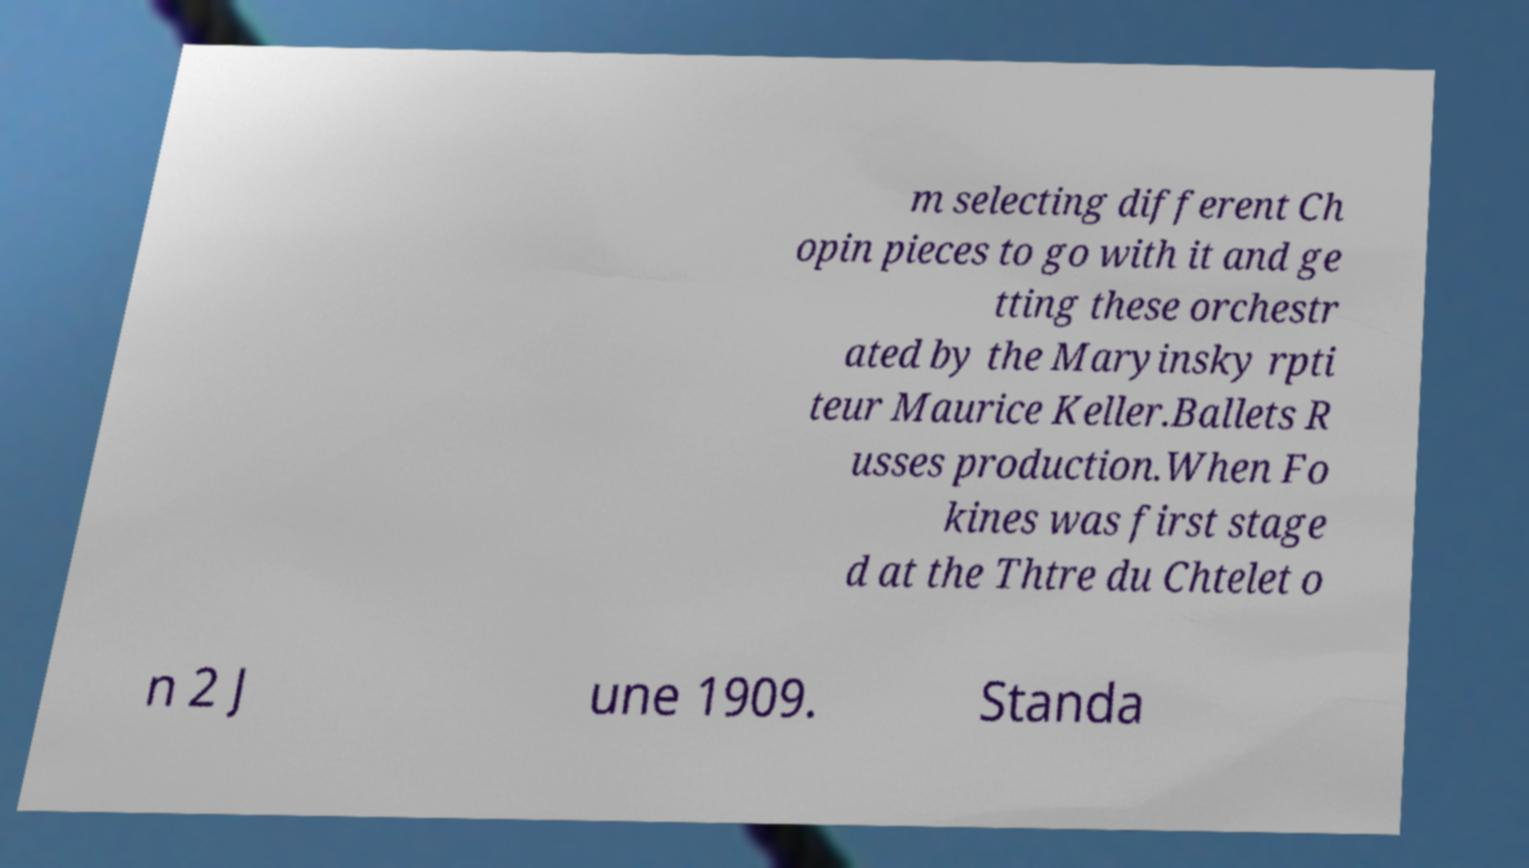For documentation purposes, I need the text within this image transcribed. Could you provide that? m selecting different Ch opin pieces to go with it and ge tting these orchestr ated by the Maryinsky rpti teur Maurice Keller.Ballets R usses production.When Fo kines was first stage d at the Thtre du Chtelet o n 2 J une 1909. Standa 